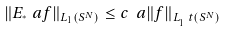<formula> <loc_0><loc_0><loc_500><loc_500>\| E _ { ^ { * } } ^ { \ } a f \| _ { L _ { 1 } ( S ^ { N } ) } \leq c _ { \ } a \| f \| _ { L _ { 1 } ^ { \ } t ( S ^ { N } ) }</formula> 